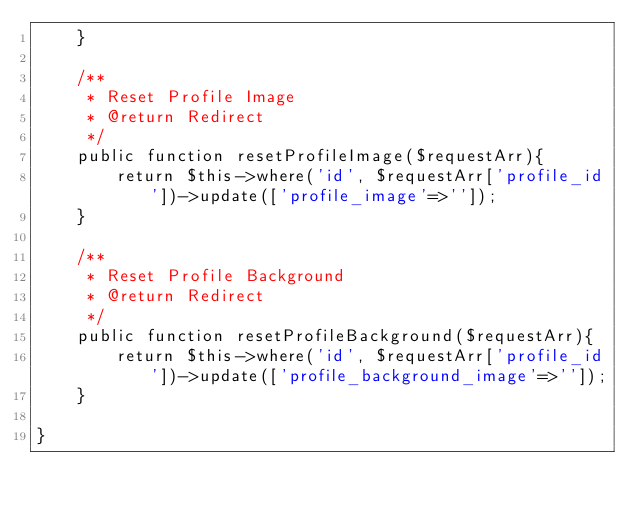<code> <loc_0><loc_0><loc_500><loc_500><_PHP_>    }

    /**
     * Reset Profile Image
     * @return Redirect
     */
    public function resetProfileImage($requestArr){
        return $this->where('id', $requestArr['profile_id'])->update(['profile_image'=>'']);
    }

    /**
     * Reset Profile Background
     * @return Redirect
     */
    public function resetProfileBackground($requestArr){
        return $this->where('id', $requestArr['profile_id'])->update(['profile_background_image'=>'']);
    }

}
</code> 